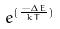Convert formula to latex. <formula><loc_0><loc_0><loc_500><loc_500>e ^ { ( \frac { - \Delta E } { k T } ) }</formula> 